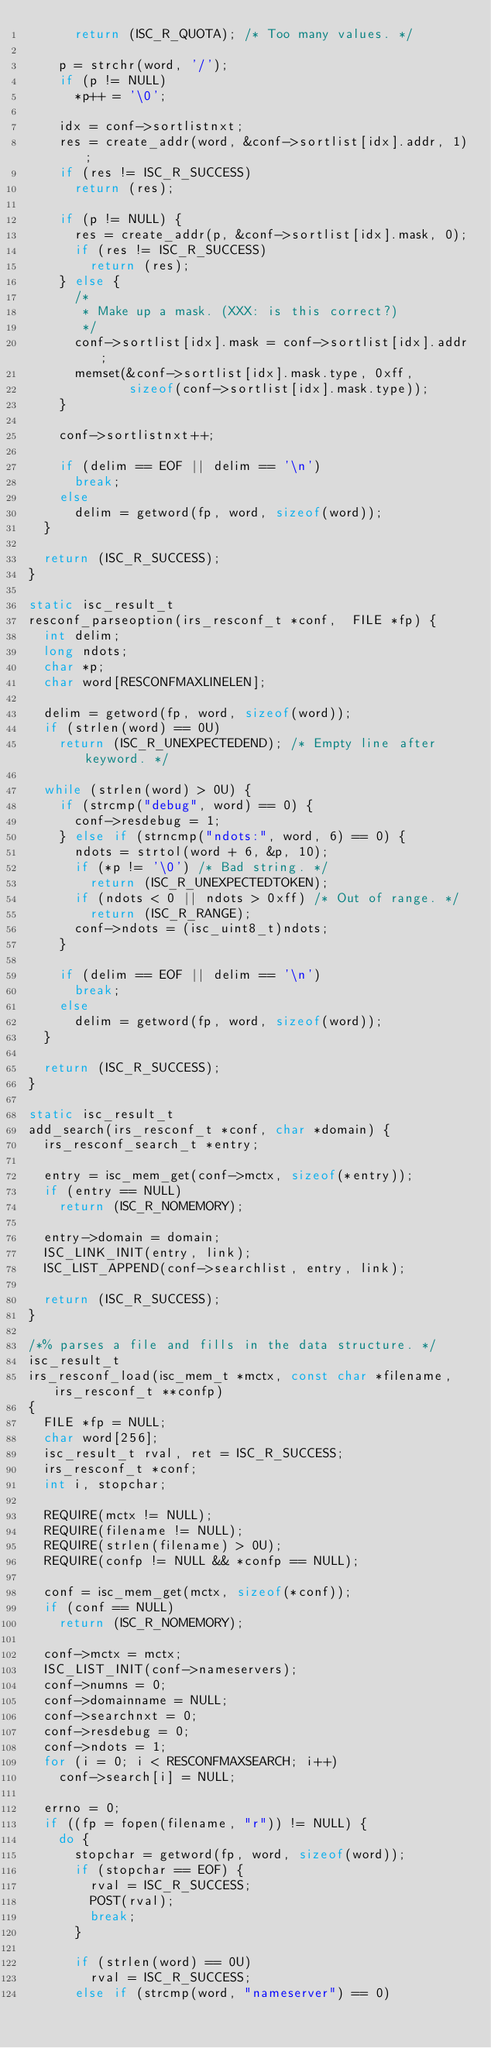<code> <loc_0><loc_0><loc_500><loc_500><_C_>			return (ISC_R_QUOTA); /* Too many values. */

		p = strchr(word, '/');
		if (p != NULL)
			*p++ = '\0';

		idx = conf->sortlistnxt;
		res = create_addr(word, &conf->sortlist[idx].addr, 1);
		if (res != ISC_R_SUCCESS)
			return (res);

		if (p != NULL) {
			res = create_addr(p, &conf->sortlist[idx].mask, 0);
			if (res != ISC_R_SUCCESS)
				return (res);
		} else {
			/*
			 * Make up a mask. (XXX: is this correct?)
			 */
			conf->sortlist[idx].mask = conf->sortlist[idx].addr;
			memset(&conf->sortlist[idx].mask.type, 0xff,
			       sizeof(conf->sortlist[idx].mask.type));
		}

		conf->sortlistnxt++;

		if (delim == EOF || delim == '\n')
			break;
		else
			delim = getword(fp, word, sizeof(word));
	}

	return (ISC_R_SUCCESS);
}

static isc_result_t
resconf_parseoption(irs_resconf_t *conf,  FILE *fp) {
	int delim;
	long ndots;
	char *p;
	char word[RESCONFMAXLINELEN];

	delim = getword(fp, word, sizeof(word));
	if (strlen(word) == 0U)
		return (ISC_R_UNEXPECTEDEND); /* Empty line after keyword. */

	while (strlen(word) > 0U) {
		if (strcmp("debug", word) == 0) {
			conf->resdebug = 1;
		} else if (strncmp("ndots:", word, 6) == 0) {
			ndots = strtol(word + 6, &p, 10);
			if (*p != '\0') /* Bad string. */
				return (ISC_R_UNEXPECTEDTOKEN);
			if (ndots < 0 || ndots > 0xff) /* Out of range. */
				return (ISC_R_RANGE);
			conf->ndots = (isc_uint8_t)ndots;
		}

		if (delim == EOF || delim == '\n')
			break;
		else
			delim = getword(fp, word, sizeof(word));
	}

	return (ISC_R_SUCCESS);
}

static isc_result_t
add_search(irs_resconf_t *conf, char *domain) {
	irs_resconf_search_t *entry;

	entry = isc_mem_get(conf->mctx, sizeof(*entry));
	if (entry == NULL)
		return (ISC_R_NOMEMORY);

	entry->domain = domain;
	ISC_LINK_INIT(entry, link);
	ISC_LIST_APPEND(conf->searchlist, entry, link);

	return (ISC_R_SUCCESS);
}

/*% parses a file and fills in the data structure. */
isc_result_t
irs_resconf_load(isc_mem_t *mctx, const char *filename, irs_resconf_t **confp)
{
	FILE *fp = NULL;
	char word[256];
	isc_result_t rval, ret = ISC_R_SUCCESS;
	irs_resconf_t *conf;
	int i, stopchar;

	REQUIRE(mctx != NULL);
	REQUIRE(filename != NULL);
	REQUIRE(strlen(filename) > 0U);
	REQUIRE(confp != NULL && *confp == NULL);

	conf = isc_mem_get(mctx, sizeof(*conf));
	if (conf == NULL)
		return (ISC_R_NOMEMORY);

	conf->mctx = mctx;
	ISC_LIST_INIT(conf->nameservers);
	conf->numns = 0;
	conf->domainname = NULL;
	conf->searchnxt = 0;
	conf->resdebug = 0;
	conf->ndots = 1;
	for (i = 0; i < RESCONFMAXSEARCH; i++)
		conf->search[i] = NULL;

	errno = 0;
	if ((fp = fopen(filename, "r")) != NULL) {
		do {
			stopchar = getword(fp, word, sizeof(word));
			if (stopchar == EOF) {
				rval = ISC_R_SUCCESS;
				POST(rval);
				break;
			}

			if (strlen(word) == 0U)
				rval = ISC_R_SUCCESS;
			else if (strcmp(word, "nameserver") == 0)</code> 